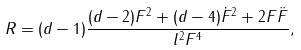<formula> <loc_0><loc_0><loc_500><loc_500>R = ( d - 1 ) \frac { ( d - 2 ) F ^ { 2 } + ( d - 4 ) \dot { F } ^ { 2 } + 2 F \ddot { F } } { l ^ { 2 } F ^ { 4 } } ,</formula> 